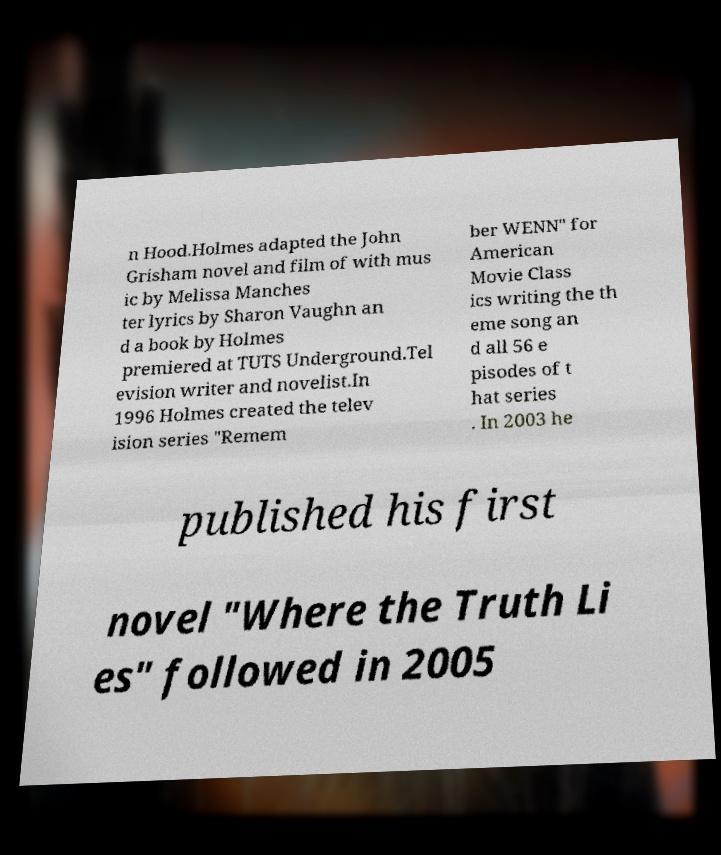Can you read and provide the text displayed in the image?This photo seems to have some interesting text. Can you extract and type it out for me? n Hood.Holmes adapted the John Grisham novel and film of with mus ic by Melissa Manches ter lyrics by Sharon Vaughn an d a book by Holmes premiered at TUTS Underground.Tel evision writer and novelist.In 1996 Holmes created the telev ision series "Remem ber WENN" for American Movie Class ics writing the th eme song an d all 56 e pisodes of t hat series . In 2003 he published his first novel "Where the Truth Li es" followed in 2005 